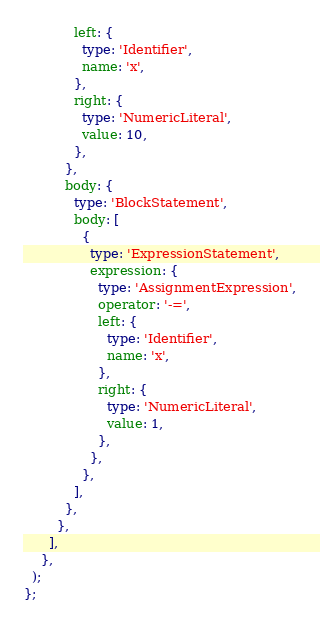<code> <loc_0><loc_0><loc_500><loc_500><_TypeScript_>            left: {
              type: 'Identifier',
              name: 'x',
            },
            right: {
              type: 'NumericLiteral',
              value: 10,
            },
          },
          body: {
            type: 'BlockStatement',
            body: [
              {
                type: 'ExpressionStatement',
                expression: {
                  type: 'AssignmentExpression',
                  operator: '-=',
                  left: {
                    type: 'Identifier',
                    name: 'x',
                  },
                  right: {
                    type: 'NumericLiteral',
                    value: 1,
                  },
                },
              },
            ],
          },
        },
      ],
    },
  );
};</code> 